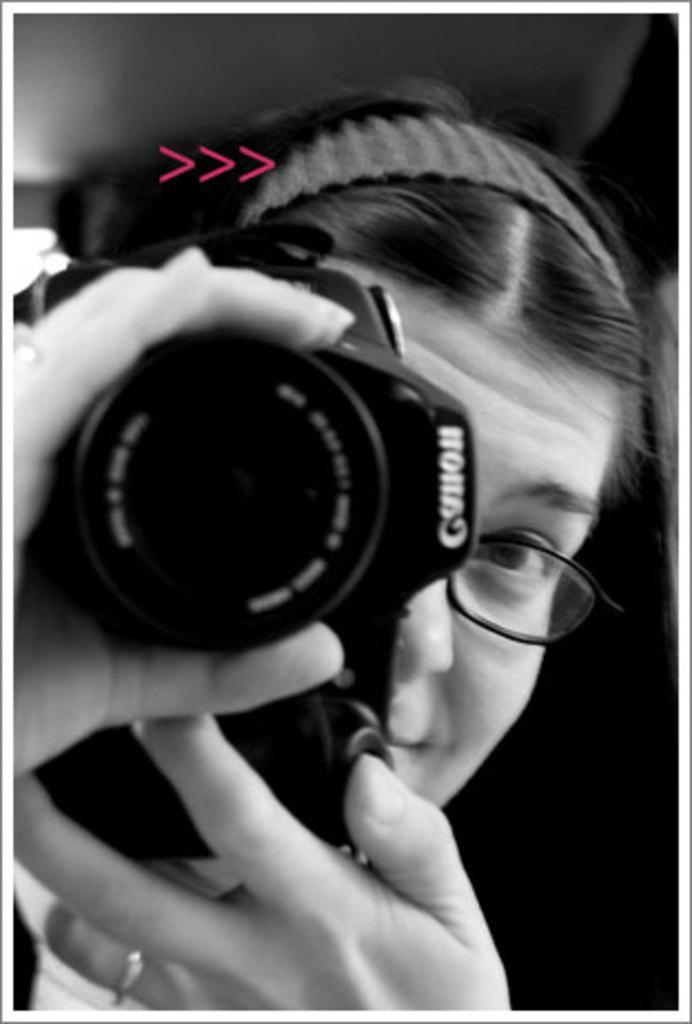What is the color scheme of the image? The image is black and white. Who is present in the image? There is a woman in the image. What is the woman holding in the image? The woman is holding a camera. Can you describe the woman's appearance in the image? The woman is wearing spectacles and a hairband. She also has a ring on her hand. What might be the woman's mood in the image? It appears that the woman is smiling in the image. What type of riddle can be seen on the woman's mask in the image? There is no mask present in the image, and therefore no riddle can be seen. 